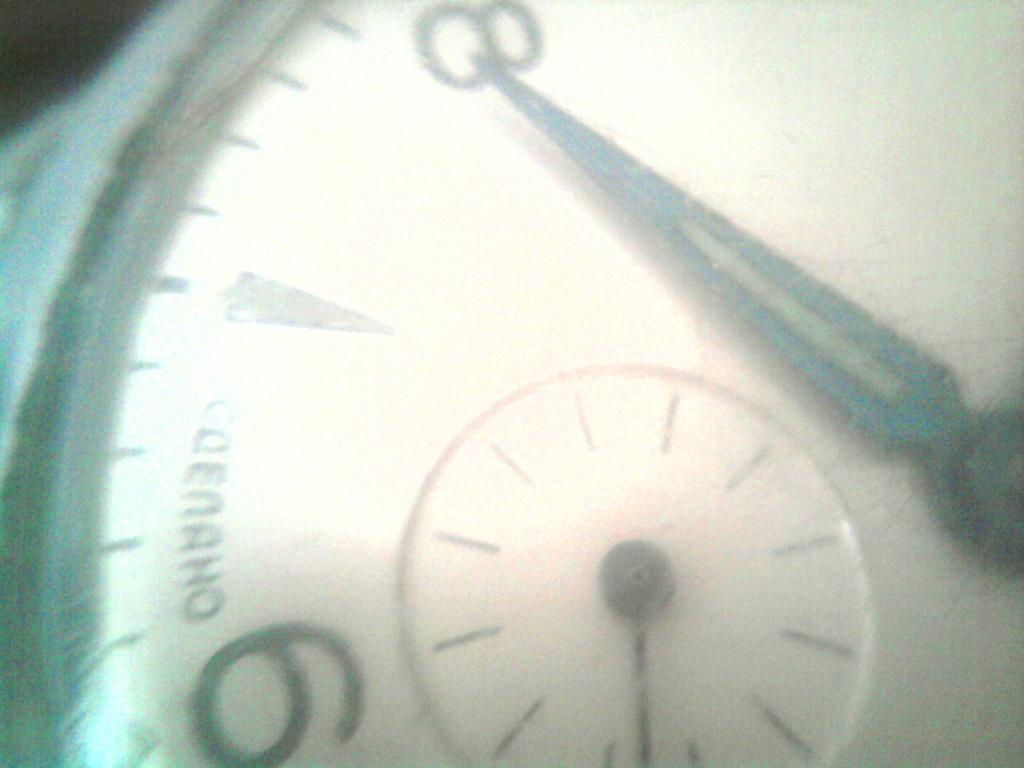<image>
Provide a brief description of the given image. Face of a watch which says the word "Codeaho" on it. 